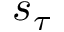<formula> <loc_0><loc_0><loc_500><loc_500>s _ { \tau }</formula> 